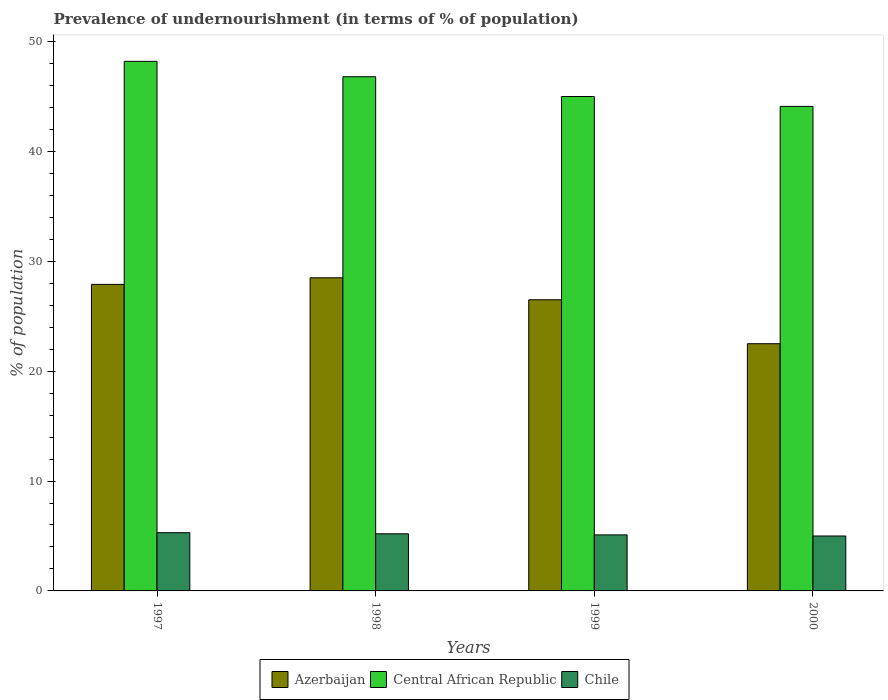Are the number of bars per tick equal to the number of legend labels?
Provide a succinct answer. Yes. Are the number of bars on each tick of the X-axis equal?
Make the answer very short. Yes. How many bars are there on the 1st tick from the right?
Offer a terse response. 3. In how many cases, is the number of bars for a given year not equal to the number of legend labels?
Your answer should be very brief. 0. Across all years, what is the minimum percentage of undernourished population in Chile?
Ensure brevity in your answer.  5. In which year was the percentage of undernourished population in Azerbaijan minimum?
Your answer should be very brief. 2000. What is the total percentage of undernourished population in Chile in the graph?
Your answer should be very brief. 20.6. What is the difference between the percentage of undernourished population in Chile in 1998 and the percentage of undernourished population in Azerbaijan in 1999?
Keep it short and to the point. -21.3. What is the average percentage of undernourished population in Chile per year?
Provide a succinct answer. 5.15. In the year 2000, what is the difference between the percentage of undernourished population in Central African Republic and percentage of undernourished population in Chile?
Provide a succinct answer. 39.1. What is the ratio of the percentage of undernourished population in Central African Republic in 1997 to that in 2000?
Give a very brief answer. 1.09. Is the difference between the percentage of undernourished population in Central African Republic in 1997 and 2000 greater than the difference between the percentage of undernourished population in Chile in 1997 and 2000?
Offer a very short reply. Yes. What is the difference between the highest and the second highest percentage of undernourished population in Central African Republic?
Your answer should be compact. 1.4. What is the difference between the highest and the lowest percentage of undernourished population in Central African Republic?
Offer a terse response. 4.1. What does the 3rd bar from the right in 1999 represents?
Your answer should be very brief. Azerbaijan. Is it the case that in every year, the sum of the percentage of undernourished population in Central African Republic and percentage of undernourished population in Chile is greater than the percentage of undernourished population in Azerbaijan?
Your response must be concise. Yes. Are all the bars in the graph horizontal?
Ensure brevity in your answer.  No. How many years are there in the graph?
Your answer should be compact. 4. Where does the legend appear in the graph?
Offer a terse response. Bottom center. What is the title of the graph?
Ensure brevity in your answer.  Prevalence of undernourishment (in terms of % of population). Does "Tajikistan" appear as one of the legend labels in the graph?
Your response must be concise. No. What is the label or title of the Y-axis?
Your response must be concise. % of population. What is the % of population in Azerbaijan in 1997?
Make the answer very short. 27.9. What is the % of population of Central African Republic in 1997?
Keep it short and to the point. 48.2. What is the % of population in Chile in 1997?
Offer a very short reply. 5.3. What is the % of population in Azerbaijan in 1998?
Offer a very short reply. 28.5. What is the % of population in Central African Republic in 1998?
Provide a succinct answer. 46.8. What is the % of population of Azerbaijan in 1999?
Keep it short and to the point. 26.5. What is the % of population of Central African Republic in 1999?
Your answer should be compact. 45. What is the % of population in Chile in 1999?
Ensure brevity in your answer.  5.1. What is the % of population of Azerbaijan in 2000?
Make the answer very short. 22.5. What is the % of population in Central African Republic in 2000?
Provide a succinct answer. 44.1. What is the % of population of Chile in 2000?
Make the answer very short. 5. Across all years, what is the maximum % of population of Central African Republic?
Offer a very short reply. 48.2. Across all years, what is the maximum % of population of Chile?
Make the answer very short. 5.3. Across all years, what is the minimum % of population of Azerbaijan?
Provide a short and direct response. 22.5. Across all years, what is the minimum % of population in Central African Republic?
Offer a very short reply. 44.1. Across all years, what is the minimum % of population in Chile?
Your answer should be very brief. 5. What is the total % of population in Azerbaijan in the graph?
Your response must be concise. 105.4. What is the total % of population in Central African Republic in the graph?
Make the answer very short. 184.1. What is the total % of population in Chile in the graph?
Give a very brief answer. 20.6. What is the difference between the % of population in Azerbaijan in 1997 and that in 1998?
Offer a very short reply. -0.6. What is the difference between the % of population in Central African Republic in 1997 and that in 1998?
Your answer should be very brief. 1.4. What is the difference between the % of population in Chile in 1997 and that in 1998?
Offer a very short reply. 0.1. What is the difference between the % of population in Chile in 1997 and that in 1999?
Your response must be concise. 0.2. What is the difference between the % of population of Chile in 1998 and that in 1999?
Provide a succinct answer. 0.1. What is the difference between the % of population of Azerbaijan in 1999 and that in 2000?
Provide a succinct answer. 4. What is the difference between the % of population in Central African Republic in 1999 and that in 2000?
Give a very brief answer. 0.9. What is the difference between the % of population of Chile in 1999 and that in 2000?
Your answer should be very brief. 0.1. What is the difference between the % of population in Azerbaijan in 1997 and the % of population in Central African Republic in 1998?
Your response must be concise. -18.9. What is the difference between the % of population of Azerbaijan in 1997 and the % of population of Chile in 1998?
Your answer should be very brief. 22.7. What is the difference between the % of population of Central African Republic in 1997 and the % of population of Chile in 1998?
Offer a terse response. 43. What is the difference between the % of population of Azerbaijan in 1997 and the % of population of Central African Republic in 1999?
Your answer should be very brief. -17.1. What is the difference between the % of population of Azerbaijan in 1997 and the % of population of Chile in 1999?
Provide a short and direct response. 22.8. What is the difference between the % of population in Central African Republic in 1997 and the % of population in Chile in 1999?
Offer a very short reply. 43.1. What is the difference between the % of population in Azerbaijan in 1997 and the % of population in Central African Republic in 2000?
Provide a succinct answer. -16.2. What is the difference between the % of population in Azerbaijan in 1997 and the % of population in Chile in 2000?
Your response must be concise. 22.9. What is the difference between the % of population of Central African Republic in 1997 and the % of population of Chile in 2000?
Your response must be concise. 43.2. What is the difference between the % of population of Azerbaijan in 1998 and the % of population of Central African Republic in 1999?
Offer a very short reply. -16.5. What is the difference between the % of population in Azerbaijan in 1998 and the % of population in Chile in 1999?
Offer a terse response. 23.4. What is the difference between the % of population of Central African Republic in 1998 and the % of population of Chile in 1999?
Provide a succinct answer. 41.7. What is the difference between the % of population of Azerbaijan in 1998 and the % of population of Central African Republic in 2000?
Ensure brevity in your answer.  -15.6. What is the difference between the % of population of Central African Republic in 1998 and the % of population of Chile in 2000?
Offer a terse response. 41.8. What is the difference between the % of population of Azerbaijan in 1999 and the % of population of Central African Republic in 2000?
Offer a terse response. -17.6. What is the difference between the % of population of Central African Republic in 1999 and the % of population of Chile in 2000?
Ensure brevity in your answer.  40. What is the average % of population of Azerbaijan per year?
Keep it short and to the point. 26.35. What is the average % of population of Central African Republic per year?
Offer a very short reply. 46.02. What is the average % of population in Chile per year?
Offer a very short reply. 5.15. In the year 1997, what is the difference between the % of population of Azerbaijan and % of population of Central African Republic?
Offer a very short reply. -20.3. In the year 1997, what is the difference between the % of population of Azerbaijan and % of population of Chile?
Offer a terse response. 22.6. In the year 1997, what is the difference between the % of population of Central African Republic and % of population of Chile?
Ensure brevity in your answer.  42.9. In the year 1998, what is the difference between the % of population of Azerbaijan and % of population of Central African Republic?
Your response must be concise. -18.3. In the year 1998, what is the difference between the % of population of Azerbaijan and % of population of Chile?
Your answer should be very brief. 23.3. In the year 1998, what is the difference between the % of population of Central African Republic and % of population of Chile?
Give a very brief answer. 41.6. In the year 1999, what is the difference between the % of population of Azerbaijan and % of population of Central African Republic?
Provide a short and direct response. -18.5. In the year 1999, what is the difference between the % of population in Azerbaijan and % of population in Chile?
Give a very brief answer. 21.4. In the year 1999, what is the difference between the % of population of Central African Republic and % of population of Chile?
Keep it short and to the point. 39.9. In the year 2000, what is the difference between the % of population of Azerbaijan and % of population of Central African Republic?
Offer a terse response. -21.6. In the year 2000, what is the difference between the % of population of Central African Republic and % of population of Chile?
Ensure brevity in your answer.  39.1. What is the ratio of the % of population of Azerbaijan in 1997 to that in 1998?
Ensure brevity in your answer.  0.98. What is the ratio of the % of population in Central African Republic in 1997 to that in 1998?
Offer a very short reply. 1.03. What is the ratio of the % of population in Chile in 1997 to that in 1998?
Provide a succinct answer. 1.02. What is the ratio of the % of population in Azerbaijan in 1997 to that in 1999?
Keep it short and to the point. 1.05. What is the ratio of the % of population in Central African Republic in 1997 to that in 1999?
Keep it short and to the point. 1.07. What is the ratio of the % of population of Chile in 1997 to that in 1999?
Offer a very short reply. 1.04. What is the ratio of the % of population in Azerbaijan in 1997 to that in 2000?
Give a very brief answer. 1.24. What is the ratio of the % of population of Central African Republic in 1997 to that in 2000?
Ensure brevity in your answer.  1.09. What is the ratio of the % of population in Chile in 1997 to that in 2000?
Offer a very short reply. 1.06. What is the ratio of the % of population in Azerbaijan in 1998 to that in 1999?
Make the answer very short. 1.08. What is the ratio of the % of population in Central African Republic in 1998 to that in 1999?
Your response must be concise. 1.04. What is the ratio of the % of population of Chile in 1998 to that in 1999?
Offer a very short reply. 1.02. What is the ratio of the % of population of Azerbaijan in 1998 to that in 2000?
Give a very brief answer. 1.27. What is the ratio of the % of population in Central African Republic in 1998 to that in 2000?
Provide a short and direct response. 1.06. What is the ratio of the % of population in Azerbaijan in 1999 to that in 2000?
Offer a terse response. 1.18. What is the ratio of the % of population of Central African Republic in 1999 to that in 2000?
Your answer should be very brief. 1.02. What is the difference between the highest and the second highest % of population in Azerbaijan?
Provide a short and direct response. 0.6. What is the difference between the highest and the second highest % of population of Chile?
Offer a very short reply. 0.1. What is the difference between the highest and the lowest % of population in Central African Republic?
Ensure brevity in your answer.  4.1. What is the difference between the highest and the lowest % of population of Chile?
Your answer should be very brief. 0.3. 